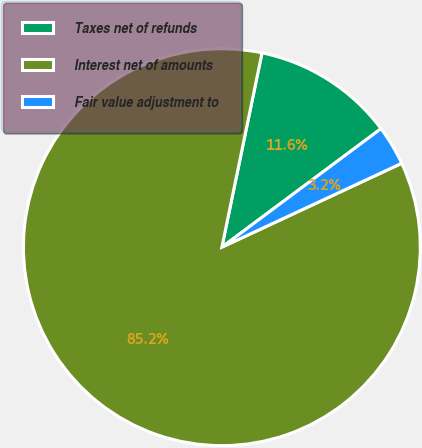<chart> <loc_0><loc_0><loc_500><loc_500><pie_chart><fcel>Taxes net of refunds<fcel>Interest net of amounts<fcel>Fair value adjustment to<nl><fcel>11.57%<fcel>85.19%<fcel>3.24%<nl></chart> 